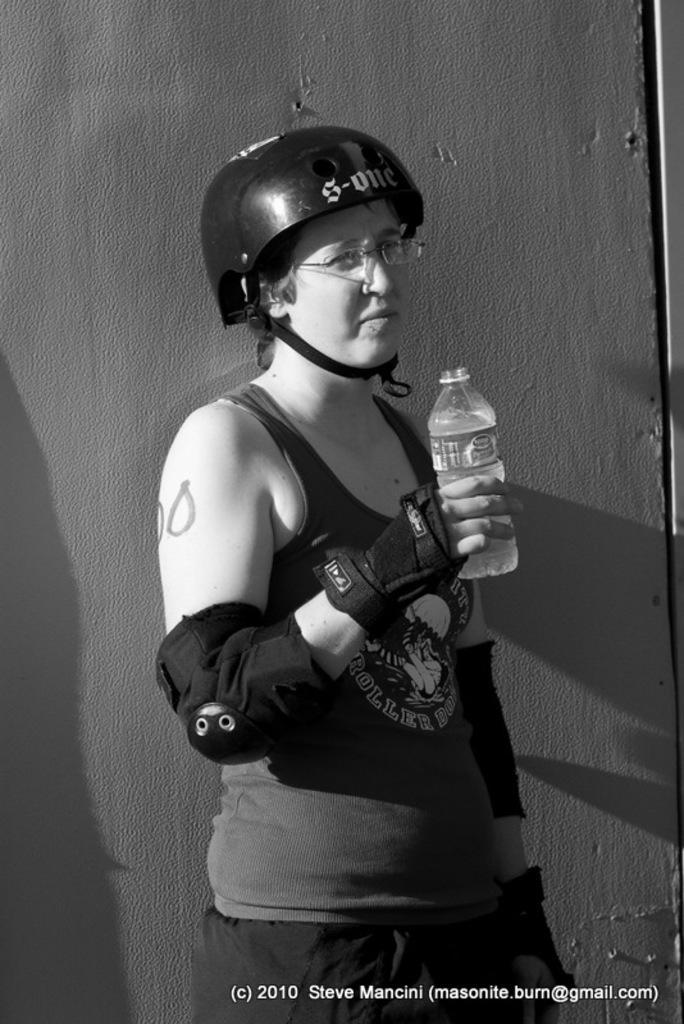Please provide a concise description of this image. In this Picture we can see girl a Wearing Helmet, Sando top, gloves and knuckle pad in her hand and Holding water bottle in the right hand standing in front of the wall. 